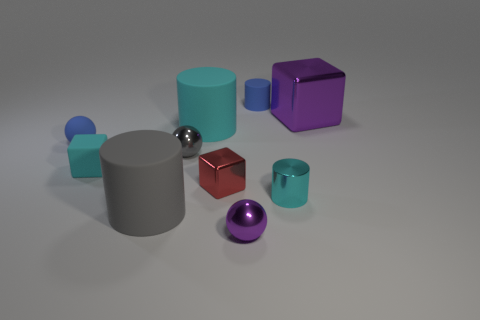Is the number of big cubes less than the number of big rubber cylinders?
Offer a very short reply. Yes. The small thing that is the same color as the metal cylinder is what shape?
Ensure brevity in your answer.  Cube. There is a cyan matte cube; how many large cylinders are in front of it?
Offer a terse response. 1. Do the large purple metal thing and the small red thing have the same shape?
Make the answer very short. Yes. What number of small objects are right of the tiny rubber cube and to the left of the large cyan matte cylinder?
Ensure brevity in your answer.  1. What number of objects are either small rubber spheres or blue objects that are in front of the large metallic cube?
Your answer should be compact. 1. Are there more small purple matte blocks than big purple things?
Your response must be concise. No. What shape is the tiny blue object that is to the left of the tiny cyan block?
Offer a terse response. Sphere. How many tiny gray things have the same shape as the red metallic thing?
Your answer should be compact. 0. There is a purple shiny object that is in front of the metal cube that is to the right of the tiny purple ball; what size is it?
Your answer should be compact. Small. 